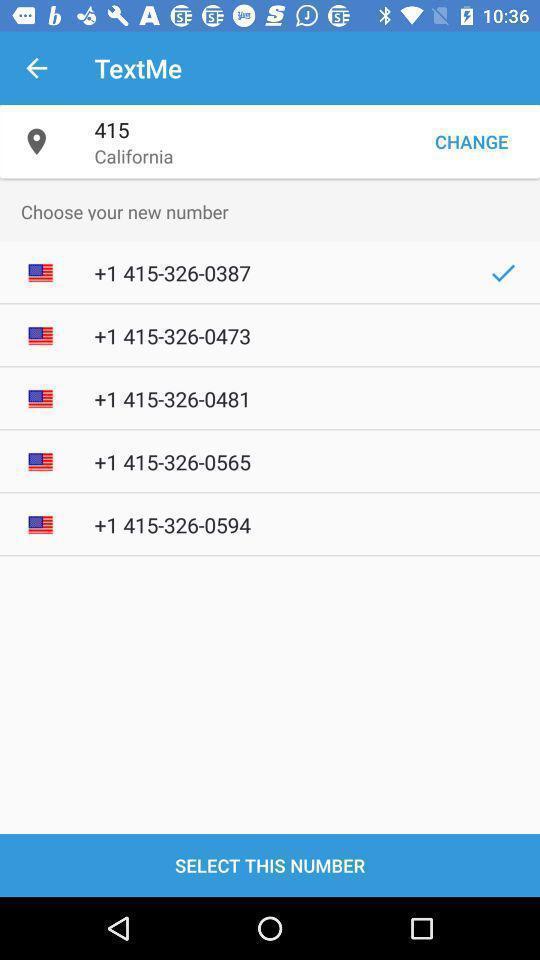Provide a description of this screenshot. Screen shows to select a number. 